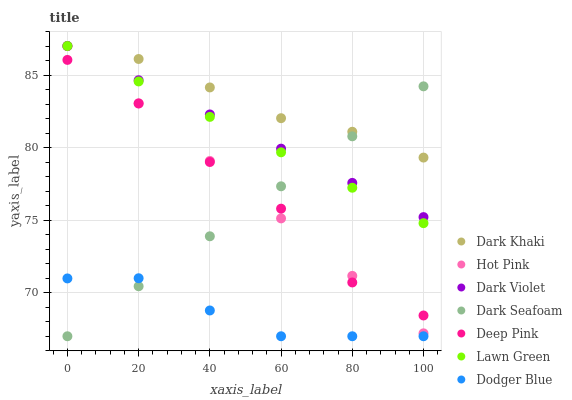Does Dodger Blue have the minimum area under the curve?
Answer yes or no. Yes. Does Dark Khaki have the maximum area under the curve?
Answer yes or no. Yes. Does Deep Pink have the minimum area under the curve?
Answer yes or no. No. Does Deep Pink have the maximum area under the curve?
Answer yes or no. No. Is Hot Pink the smoothest?
Answer yes or no. Yes. Is Deep Pink the roughest?
Answer yes or no. Yes. Is Deep Pink the smoothest?
Answer yes or no. No. Is Hot Pink the roughest?
Answer yes or no. No. Does Dark Seafoam have the lowest value?
Answer yes or no. Yes. Does Deep Pink have the lowest value?
Answer yes or no. No. Does Dark Khaki have the highest value?
Answer yes or no. Yes. Does Deep Pink have the highest value?
Answer yes or no. No. Is Deep Pink less than Dark Violet?
Answer yes or no. Yes. Is Deep Pink greater than Dodger Blue?
Answer yes or no. Yes. Does Dark Violet intersect Dark Khaki?
Answer yes or no. Yes. Is Dark Violet less than Dark Khaki?
Answer yes or no. No. Is Dark Violet greater than Dark Khaki?
Answer yes or no. No. Does Deep Pink intersect Dark Violet?
Answer yes or no. No. 